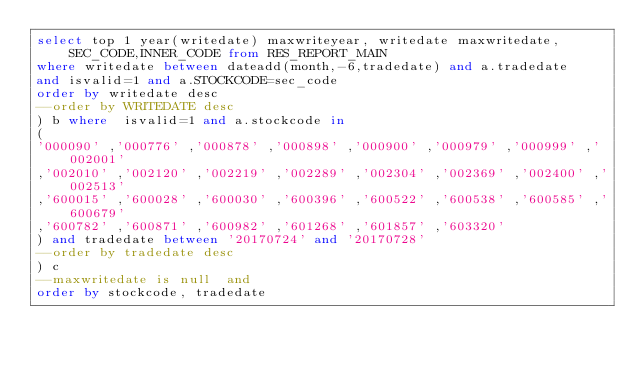<code> <loc_0><loc_0><loc_500><loc_500><_SQL_>select top 1 year(writedate) maxwriteyear, writedate maxwritedate,SEC_CODE,INNER_CODE from RES_REPORT_MAIN
where writedate between dateadd(month,-6,tradedate) and a.tradedate 
and isvalid=1 and a.STOCKCODE=sec_code
order by writedate desc
--order by WRITEDATE desc
) b where  isvalid=1 and a.stockcode in
(
'000090' ,'000776' ,'000878' ,'000898' ,'000900' ,'000979' ,'000999' ,'002001'  
,'002010' ,'002120' ,'002219' ,'002289' ,'002304' ,'002369' ,'002400' ,'002513'  
,'600015' ,'600028' ,'600030' ,'600396' ,'600522' ,'600538' ,'600585' ,'600679'  
,'600782' ,'600871' ,'600982' ,'601268' ,'601857' ,'603320' 
) and tradedate between '20170724' and '20170728'
--order by tradedate desc
) c 
--maxwritedate is null  and 
order by stockcode, tradedate 
</code> 